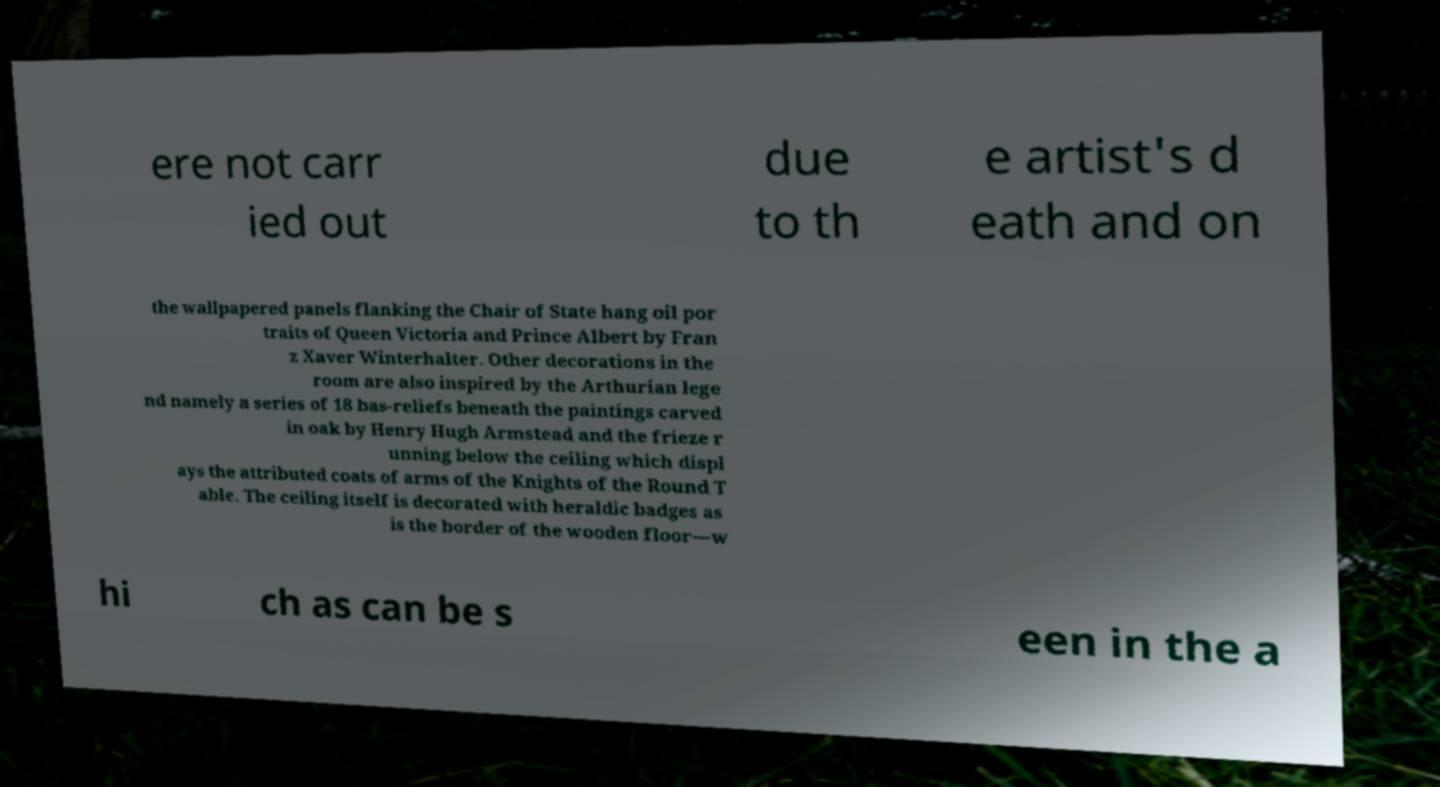Please read and relay the text visible in this image. What does it say? ere not carr ied out due to th e artist's d eath and on the wallpapered panels flanking the Chair of State hang oil por traits of Queen Victoria and Prince Albert by Fran z Xaver Winterhalter. Other decorations in the room are also inspired by the Arthurian lege nd namely a series of 18 bas-reliefs beneath the paintings carved in oak by Henry Hugh Armstead and the frieze r unning below the ceiling which displ ays the attributed coats of arms of the Knights of the Round T able. The ceiling itself is decorated with heraldic badges as is the border of the wooden floor—w hi ch as can be s een in the a 